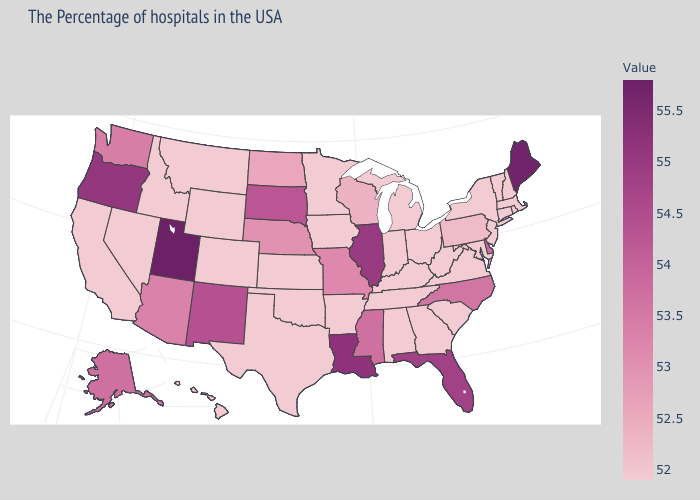Which states have the highest value in the USA?
Keep it brief. Utah. Does Florida have a lower value than Utah?
Short answer required. Yes. Does the map have missing data?
Keep it brief. No. Does Missouri have the highest value in the MidWest?
Answer briefly. No. Among the states that border New York , does Pennsylvania have the highest value?
Quick response, please. Yes. 